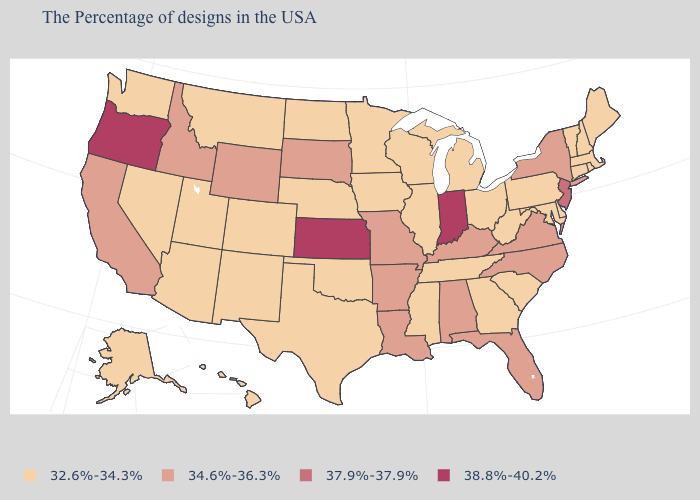What is the value of North Dakota?
Be succinct. 32.6%-34.3%. How many symbols are there in the legend?
Be succinct. 4. What is the value of Rhode Island?
Give a very brief answer. 32.6%-34.3%. Among the states that border Florida , which have the lowest value?
Write a very short answer. Georgia. Does Louisiana have the lowest value in the South?
Answer briefly. No. How many symbols are there in the legend?
Answer briefly. 4. What is the value of Wyoming?
Short answer required. 34.6%-36.3%. What is the value of Iowa?
Be succinct. 32.6%-34.3%. What is the lowest value in the USA?
Give a very brief answer. 32.6%-34.3%. Name the states that have a value in the range 34.6%-36.3%?
Concise answer only. New York, Virginia, North Carolina, Florida, Kentucky, Alabama, Louisiana, Missouri, Arkansas, South Dakota, Wyoming, Idaho, California. Which states have the lowest value in the MidWest?
Be succinct. Ohio, Michigan, Wisconsin, Illinois, Minnesota, Iowa, Nebraska, North Dakota. Among the states that border Maine , which have the lowest value?
Keep it brief. New Hampshire. Name the states that have a value in the range 32.6%-34.3%?
Give a very brief answer. Maine, Massachusetts, Rhode Island, New Hampshire, Vermont, Connecticut, Delaware, Maryland, Pennsylvania, South Carolina, West Virginia, Ohio, Georgia, Michigan, Tennessee, Wisconsin, Illinois, Mississippi, Minnesota, Iowa, Nebraska, Oklahoma, Texas, North Dakota, Colorado, New Mexico, Utah, Montana, Arizona, Nevada, Washington, Alaska, Hawaii. Does Oregon have the highest value in the USA?
Give a very brief answer. Yes. 